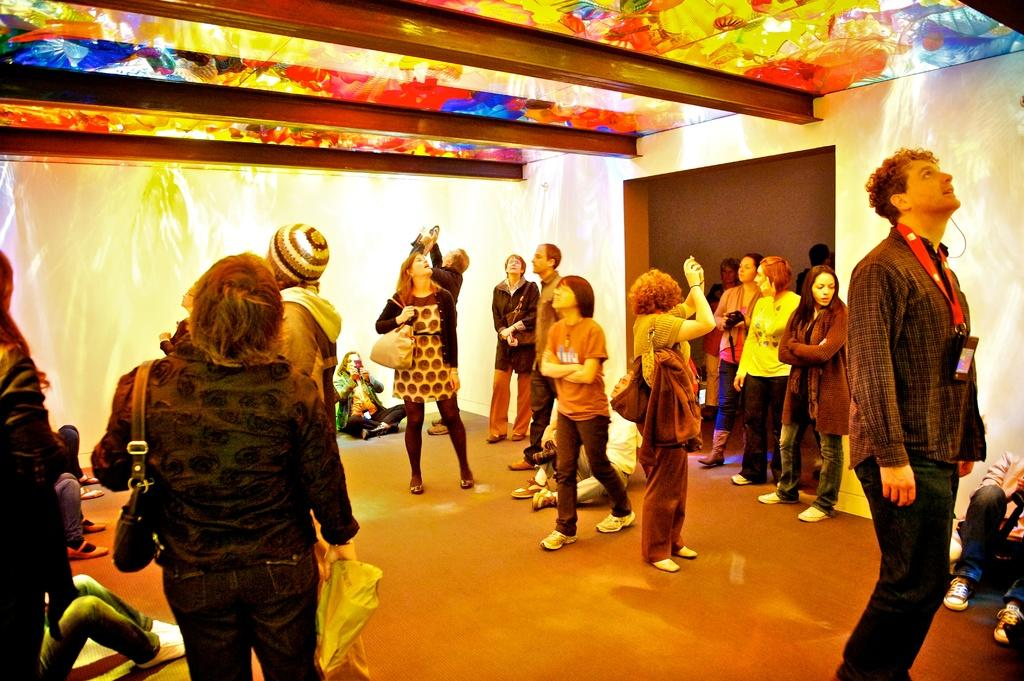What can be seen in the image? There is a group of people in the image. How are the people dressed? The people are wearing different color dresses. What else can be observed about the people in the image? Some people in the group are wearing bags. What can be seen above the people in the image? There is a colorful ceiling visible in the image. Are there any children participating in the event in the image? There is no mention of an event or children in the image; it simply shows a group of people wearing different color dresses and some wearing bags. 